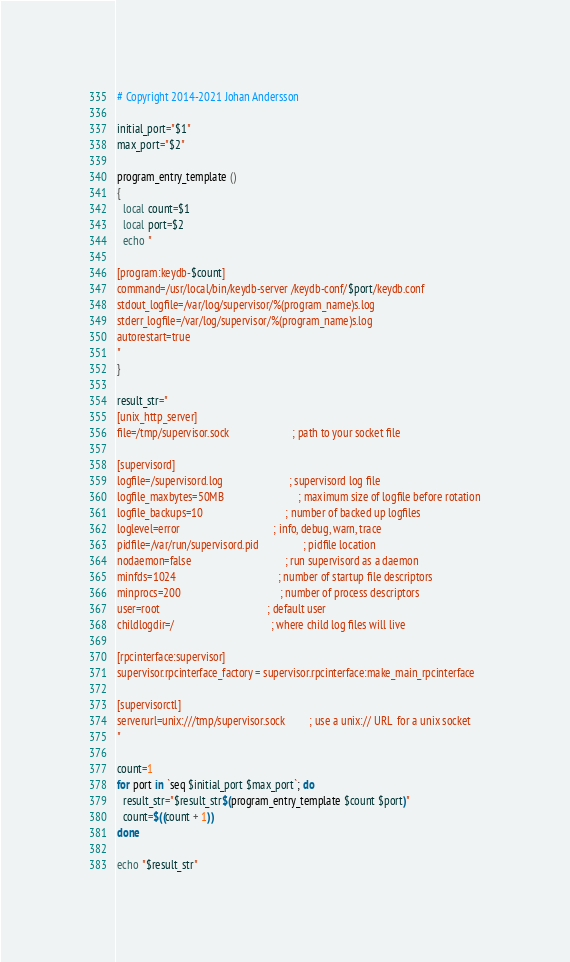Convert code to text. <code><loc_0><loc_0><loc_500><loc_500><_Bash_># Copyright 2014-2021 Johan Andersson

initial_port="$1"
max_port="$2"

program_entry_template ()
{
  local count=$1
  local port=$2
  echo "

[program:keydb-$count]
command=/usr/local/bin/keydb-server /keydb-conf/$port/keydb.conf
stdout_logfile=/var/log/supervisor/%(program_name)s.log
stderr_logfile=/var/log/supervisor/%(program_name)s.log
autorestart=true
"
}

result_str="
[unix_http_server]
file=/tmp/supervisor.sock                       ; path to your socket file

[supervisord]
logfile=/supervisord.log                        ; supervisord log file
logfile_maxbytes=50MB                           ; maximum size of logfile before rotation
logfile_backups=10                              ; number of backed up logfiles
loglevel=error                                  ; info, debug, warn, trace
pidfile=/var/run/supervisord.pid                ; pidfile location
nodaemon=false                                  ; run supervisord as a daemon
minfds=1024                                     ; number of startup file descriptors
minprocs=200                                    ; number of process descriptors
user=root                                       ; default user
childlogdir=/                                   ; where child log files will live

[rpcinterface:supervisor]
supervisor.rpcinterface_factory = supervisor.rpcinterface:make_main_rpcinterface

[supervisorctl]
serverurl=unix:///tmp/supervisor.sock         ; use a unix:// URL  for a unix socket
"

count=1
for port in `seq $initial_port $max_port`; do
  result_str="$result_str$(program_entry_template $count $port)"
  count=$((count + 1))
done

echo "$result_str"
</code> 